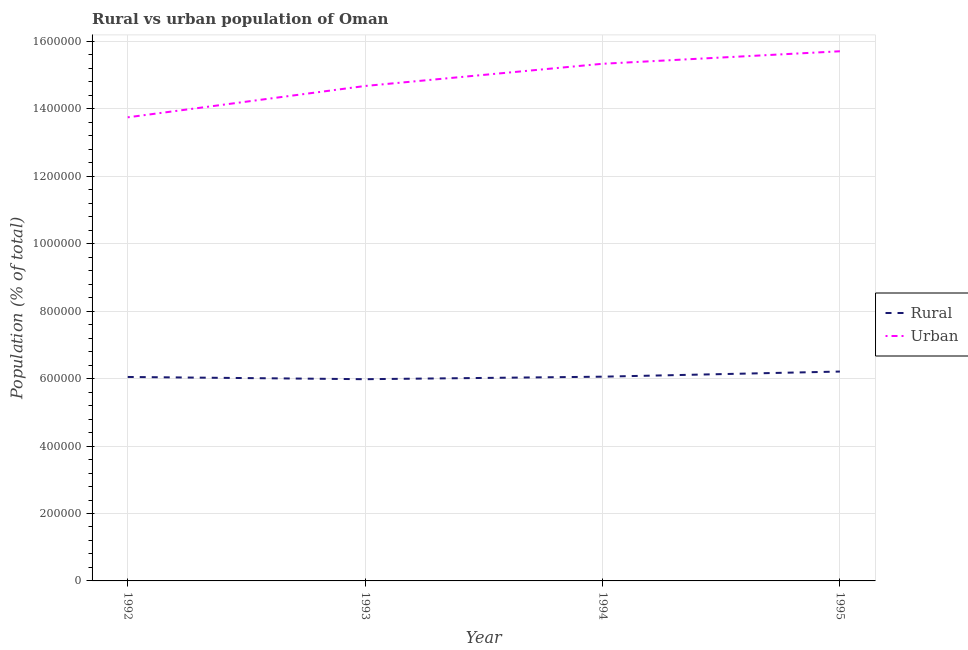How many different coloured lines are there?
Offer a very short reply. 2. Does the line corresponding to rural population density intersect with the line corresponding to urban population density?
Offer a terse response. No. What is the urban population density in 1993?
Your answer should be compact. 1.47e+06. Across all years, what is the maximum urban population density?
Your response must be concise. 1.57e+06. Across all years, what is the minimum urban population density?
Keep it short and to the point. 1.37e+06. What is the total rural population density in the graph?
Provide a short and direct response. 2.43e+06. What is the difference between the urban population density in 1993 and that in 1994?
Provide a short and direct response. -6.58e+04. What is the difference between the urban population density in 1994 and the rural population density in 1995?
Your answer should be very brief. 9.13e+05. What is the average urban population density per year?
Provide a succinct answer. 1.49e+06. In the year 1993, what is the difference between the rural population density and urban population density?
Your response must be concise. -8.70e+05. What is the ratio of the urban population density in 1994 to that in 1995?
Keep it short and to the point. 0.98. What is the difference between the highest and the second highest rural population density?
Give a very brief answer. 1.52e+04. What is the difference between the highest and the lowest urban population density?
Your answer should be compact. 1.96e+05. In how many years, is the rural population density greater than the average rural population density taken over all years?
Your answer should be compact. 1. Is the sum of the urban population density in 1993 and 1994 greater than the maximum rural population density across all years?
Offer a very short reply. Yes. Does the graph contain any zero values?
Ensure brevity in your answer.  No. How are the legend labels stacked?
Give a very brief answer. Vertical. What is the title of the graph?
Offer a very short reply. Rural vs urban population of Oman. Does "Drinking water services" appear as one of the legend labels in the graph?
Keep it short and to the point. No. What is the label or title of the Y-axis?
Your answer should be very brief. Population (% of total). What is the Population (% of total) in Rural in 1992?
Ensure brevity in your answer.  6.05e+05. What is the Population (% of total) of Urban in 1992?
Your response must be concise. 1.37e+06. What is the Population (% of total) of Rural in 1993?
Make the answer very short. 5.98e+05. What is the Population (% of total) in Urban in 1993?
Your response must be concise. 1.47e+06. What is the Population (% of total) in Rural in 1994?
Make the answer very short. 6.06e+05. What is the Population (% of total) of Urban in 1994?
Give a very brief answer. 1.53e+06. What is the Population (% of total) of Rural in 1995?
Your answer should be very brief. 6.21e+05. What is the Population (% of total) of Urban in 1995?
Ensure brevity in your answer.  1.57e+06. Across all years, what is the maximum Population (% of total) in Rural?
Offer a very short reply. 6.21e+05. Across all years, what is the maximum Population (% of total) in Urban?
Offer a terse response. 1.57e+06. Across all years, what is the minimum Population (% of total) in Rural?
Offer a very short reply. 5.98e+05. Across all years, what is the minimum Population (% of total) in Urban?
Your response must be concise. 1.37e+06. What is the total Population (% of total) in Rural in the graph?
Provide a short and direct response. 2.43e+06. What is the total Population (% of total) of Urban in the graph?
Provide a short and direct response. 5.95e+06. What is the difference between the Population (% of total) of Rural in 1992 and that in 1993?
Keep it short and to the point. 6616. What is the difference between the Population (% of total) of Urban in 1992 and that in 1993?
Your response must be concise. -9.30e+04. What is the difference between the Population (% of total) in Rural in 1992 and that in 1994?
Give a very brief answer. -823. What is the difference between the Population (% of total) of Urban in 1992 and that in 1994?
Offer a very short reply. -1.59e+05. What is the difference between the Population (% of total) of Rural in 1992 and that in 1995?
Provide a short and direct response. -1.61e+04. What is the difference between the Population (% of total) in Urban in 1992 and that in 1995?
Offer a terse response. -1.96e+05. What is the difference between the Population (% of total) in Rural in 1993 and that in 1994?
Ensure brevity in your answer.  -7439. What is the difference between the Population (% of total) of Urban in 1993 and that in 1994?
Your answer should be very brief. -6.58e+04. What is the difference between the Population (% of total) in Rural in 1993 and that in 1995?
Offer a terse response. -2.27e+04. What is the difference between the Population (% of total) of Urban in 1993 and that in 1995?
Provide a succinct answer. -1.03e+05. What is the difference between the Population (% of total) in Rural in 1994 and that in 1995?
Your answer should be compact. -1.52e+04. What is the difference between the Population (% of total) in Urban in 1994 and that in 1995?
Provide a short and direct response. -3.71e+04. What is the difference between the Population (% of total) of Rural in 1992 and the Population (% of total) of Urban in 1993?
Your answer should be compact. -8.63e+05. What is the difference between the Population (% of total) in Rural in 1992 and the Population (% of total) in Urban in 1994?
Your answer should be very brief. -9.29e+05. What is the difference between the Population (% of total) in Rural in 1992 and the Population (% of total) in Urban in 1995?
Your response must be concise. -9.66e+05. What is the difference between the Population (% of total) in Rural in 1993 and the Population (% of total) in Urban in 1994?
Offer a very short reply. -9.35e+05. What is the difference between the Population (% of total) in Rural in 1993 and the Population (% of total) in Urban in 1995?
Your answer should be very brief. -9.73e+05. What is the difference between the Population (% of total) of Rural in 1994 and the Population (% of total) of Urban in 1995?
Make the answer very short. -9.65e+05. What is the average Population (% of total) of Rural per year?
Ensure brevity in your answer.  6.07e+05. What is the average Population (% of total) in Urban per year?
Give a very brief answer. 1.49e+06. In the year 1992, what is the difference between the Population (% of total) in Rural and Population (% of total) in Urban?
Your answer should be very brief. -7.70e+05. In the year 1993, what is the difference between the Population (% of total) in Rural and Population (% of total) in Urban?
Your answer should be very brief. -8.70e+05. In the year 1994, what is the difference between the Population (% of total) of Rural and Population (% of total) of Urban?
Your response must be concise. -9.28e+05. In the year 1995, what is the difference between the Population (% of total) of Rural and Population (% of total) of Urban?
Offer a very short reply. -9.50e+05. What is the ratio of the Population (% of total) of Rural in 1992 to that in 1993?
Ensure brevity in your answer.  1.01. What is the ratio of the Population (% of total) of Urban in 1992 to that in 1993?
Provide a succinct answer. 0.94. What is the ratio of the Population (% of total) in Urban in 1992 to that in 1994?
Offer a very short reply. 0.9. What is the ratio of the Population (% of total) of Rural in 1992 to that in 1995?
Your answer should be compact. 0.97. What is the ratio of the Population (% of total) in Urban in 1992 to that in 1995?
Make the answer very short. 0.88. What is the ratio of the Population (% of total) in Rural in 1993 to that in 1994?
Your answer should be very brief. 0.99. What is the ratio of the Population (% of total) in Urban in 1993 to that in 1994?
Your answer should be very brief. 0.96. What is the ratio of the Population (% of total) of Rural in 1993 to that in 1995?
Keep it short and to the point. 0.96. What is the ratio of the Population (% of total) of Urban in 1993 to that in 1995?
Your response must be concise. 0.93. What is the ratio of the Population (% of total) in Rural in 1994 to that in 1995?
Provide a short and direct response. 0.98. What is the ratio of the Population (% of total) of Urban in 1994 to that in 1995?
Your answer should be compact. 0.98. What is the difference between the highest and the second highest Population (% of total) of Rural?
Give a very brief answer. 1.52e+04. What is the difference between the highest and the second highest Population (% of total) of Urban?
Your answer should be compact. 3.71e+04. What is the difference between the highest and the lowest Population (% of total) in Rural?
Provide a short and direct response. 2.27e+04. What is the difference between the highest and the lowest Population (% of total) of Urban?
Keep it short and to the point. 1.96e+05. 